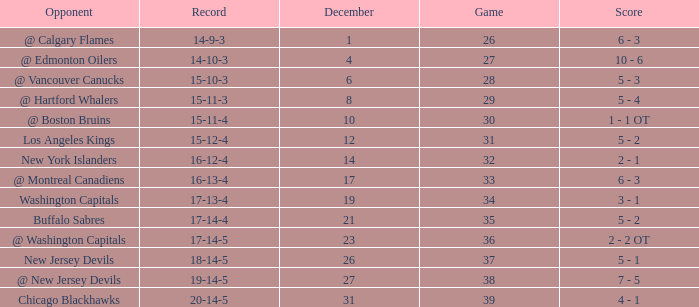Record of 15-12-4, and a Game larger than 31 involves what highest December? None. 